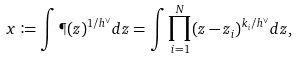Convert formula to latex. <formula><loc_0><loc_0><loc_500><loc_500>x \coloneqq \int \P ( z ) ^ { 1 / h ^ { \vee } } d z = \int \prod _ { i = 1 } ^ { N } ( z - z _ { i } ) ^ { k _ { i } / h ^ { \vee } } d z ,</formula> 